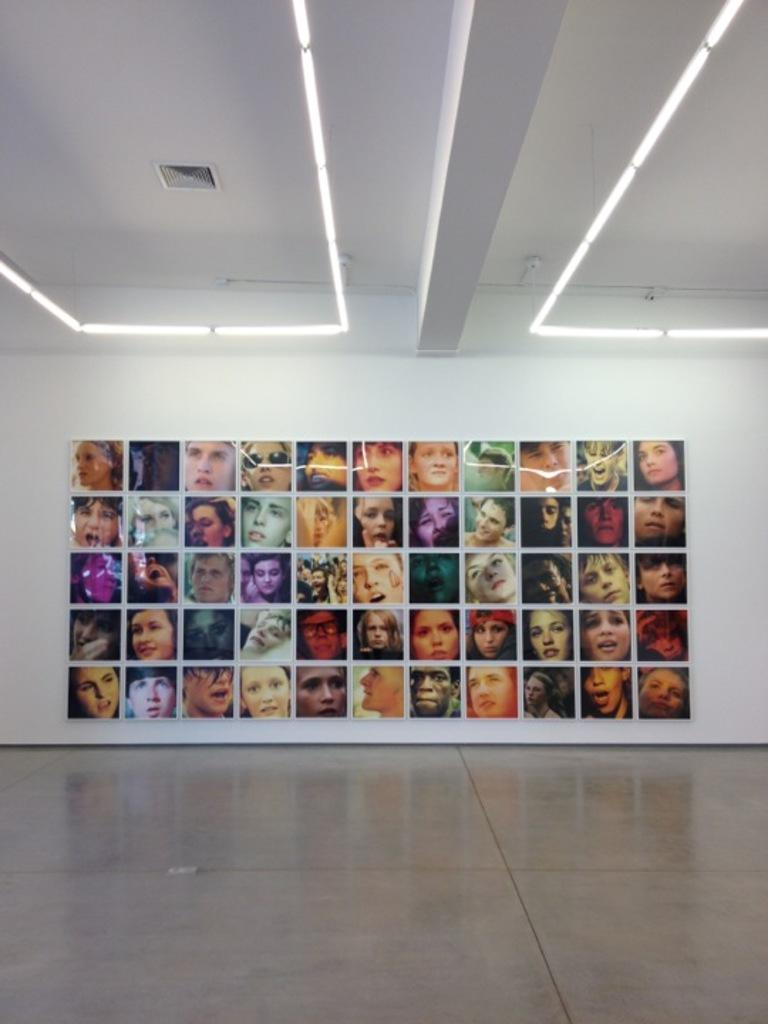What is attached to the wall in the image? There are pictures attached to the wall in the image. What color is the wall in the image? The wall is white in color. What can be seen providing illumination in the image? There are lights visible in the image. What type of drink is being served on the island in the image? There is no island or drink present in the image; it only features pictures attached to a white wall and visible lights. 